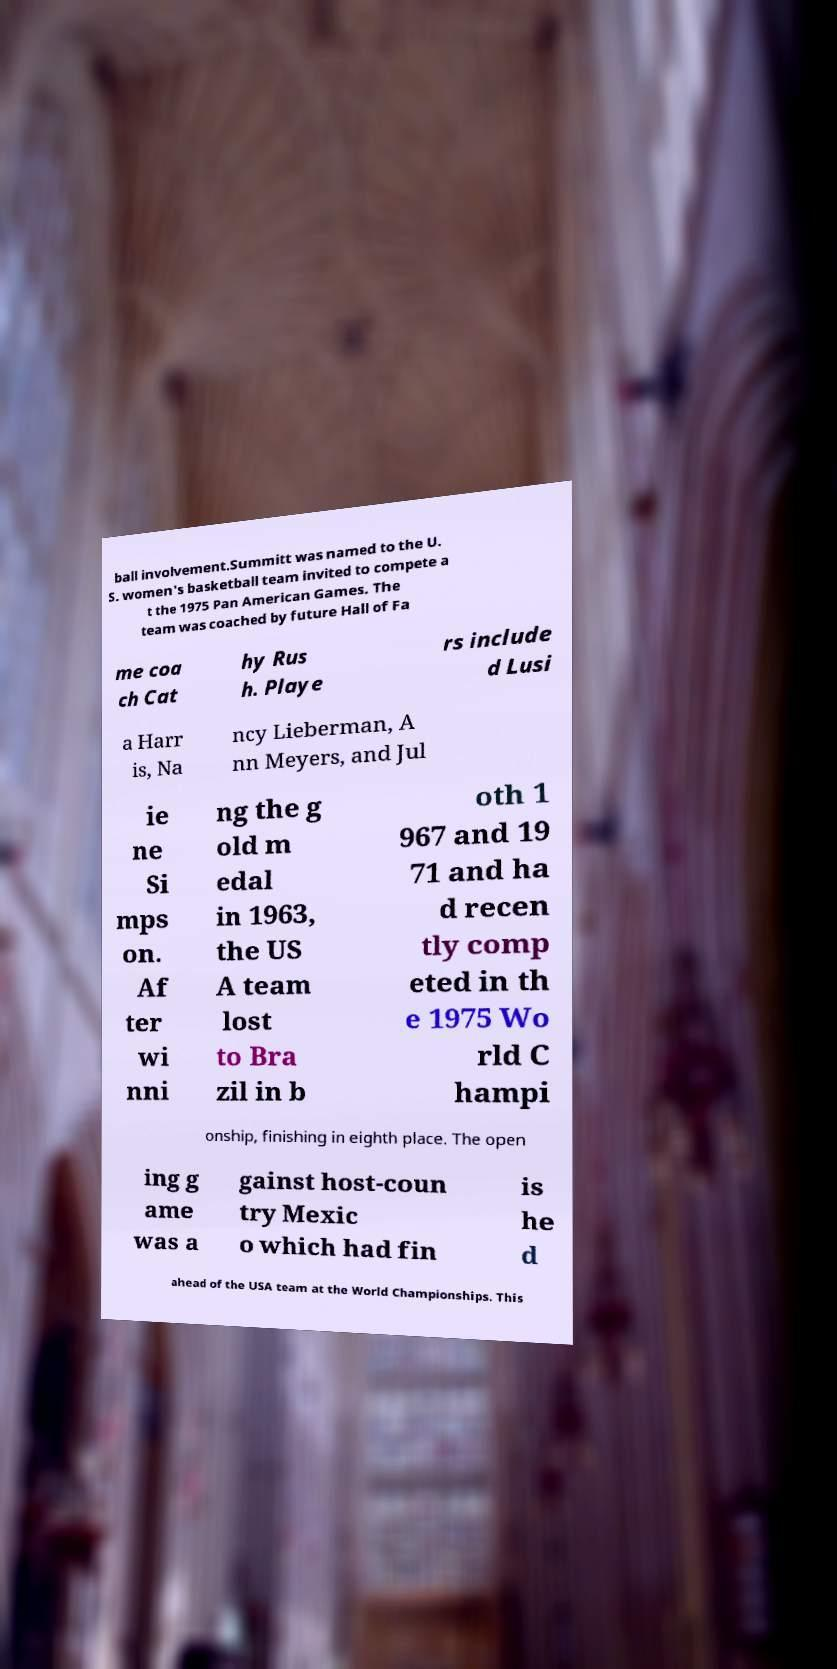Please read and relay the text visible in this image. What does it say? ball involvement.Summitt was named to the U. S. women's basketball team invited to compete a t the 1975 Pan American Games. The team was coached by future Hall of Fa me coa ch Cat hy Rus h. Playe rs include d Lusi a Harr is, Na ncy Lieberman, A nn Meyers, and Jul ie ne Si mps on. Af ter wi nni ng the g old m edal in 1963, the US A team lost to Bra zil in b oth 1 967 and 19 71 and ha d recen tly comp eted in th e 1975 Wo rld C hampi onship, finishing in eighth place. The open ing g ame was a gainst host-coun try Mexic o which had fin is he d ahead of the USA team at the World Championships. This 